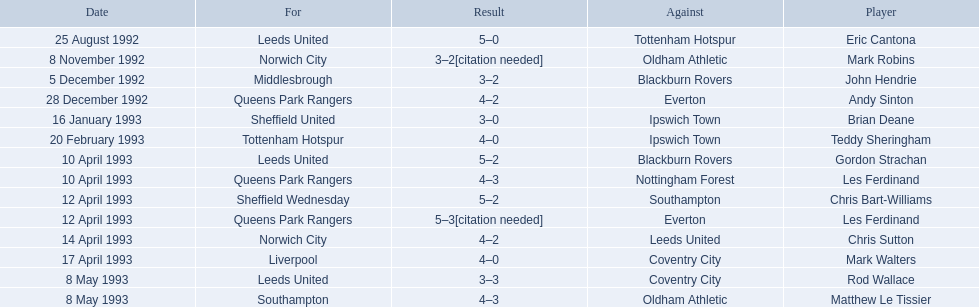What are the results? 5–0, 3–2[citation needed], 3–2, 4–2, 3–0, 4–0, 5–2, 4–3, 5–2, 5–3[citation needed], 4–2, 4–0, 3–3, 4–3. What result did mark robins have? 3–2[citation needed]. What other player had that result? John Hendrie. 